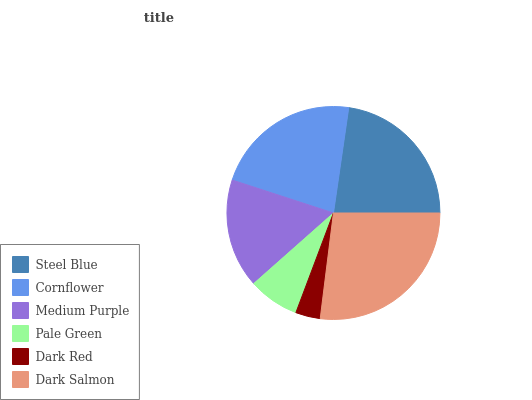Is Dark Red the minimum?
Answer yes or no. Yes. Is Dark Salmon the maximum?
Answer yes or no. Yes. Is Cornflower the minimum?
Answer yes or no. No. Is Cornflower the maximum?
Answer yes or no. No. Is Steel Blue greater than Cornflower?
Answer yes or no. Yes. Is Cornflower less than Steel Blue?
Answer yes or no. Yes. Is Cornflower greater than Steel Blue?
Answer yes or no. No. Is Steel Blue less than Cornflower?
Answer yes or no. No. Is Cornflower the high median?
Answer yes or no. Yes. Is Medium Purple the low median?
Answer yes or no. Yes. Is Pale Green the high median?
Answer yes or no. No. Is Pale Green the low median?
Answer yes or no. No. 